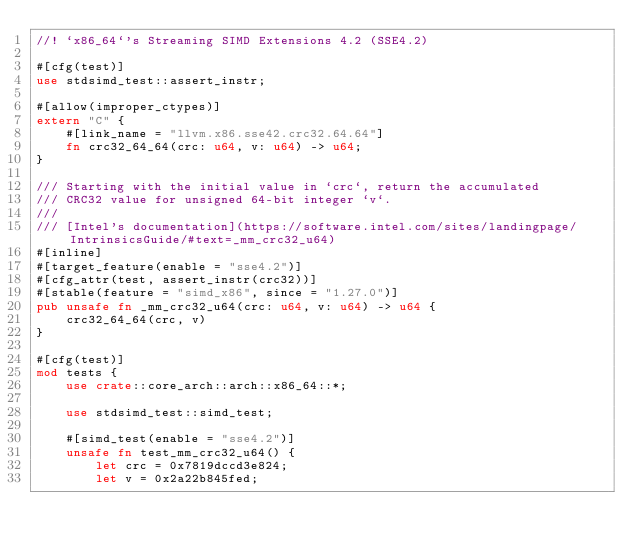<code> <loc_0><loc_0><loc_500><loc_500><_Rust_>//! `x86_64`'s Streaming SIMD Extensions 4.2 (SSE4.2)

#[cfg(test)]
use stdsimd_test::assert_instr;

#[allow(improper_ctypes)]
extern "C" {
    #[link_name = "llvm.x86.sse42.crc32.64.64"]
    fn crc32_64_64(crc: u64, v: u64) -> u64;
}

/// Starting with the initial value in `crc`, return the accumulated
/// CRC32 value for unsigned 64-bit integer `v`.
///
/// [Intel's documentation](https://software.intel.com/sites/landingpage/IntrinsicsGuide/#text=_mm_crc32_u64)
#[inline]
#[target_feature(enable = "sse4.2")]
#[cfg_attr(test, assert_instr(crc32))]
#[stable(feature = "simd_x86", since = "1.27.0")]
pub unsafe fn _mm_crc32_u64(crc: u64, v: u64) -> u64 {
    crc32_64_64(crc, v)
}

#[cfg(test)]
mod tests {
    use crate::core_arch::arch::x86_64::*;

    use stdsimd_test::simd_test;

    #[simd_test(enable = "sse4.2")]
    unsafe fn test_mm_crc32_u64() {
        let crc = 0x7819dccd3e824;
        let v = 0x2a22b845fed;</code> 